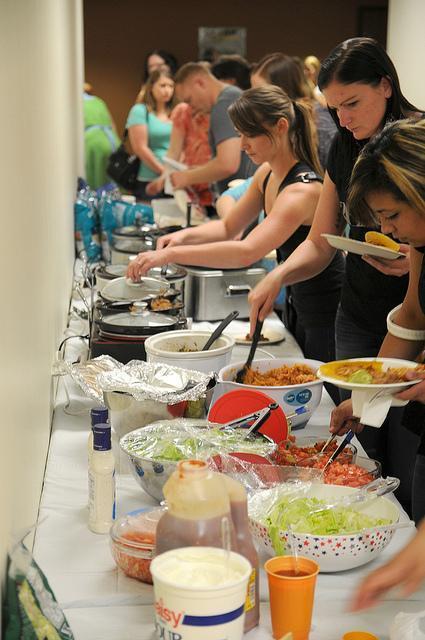How many kids are in the scene?
Give a very brief answer. 0. How many bowls are there?
Give a very brief answer. 5. How many bottles are visible?
Give a very brief answer. 1. How many people can you see?
Give a very brief answer. 7. 